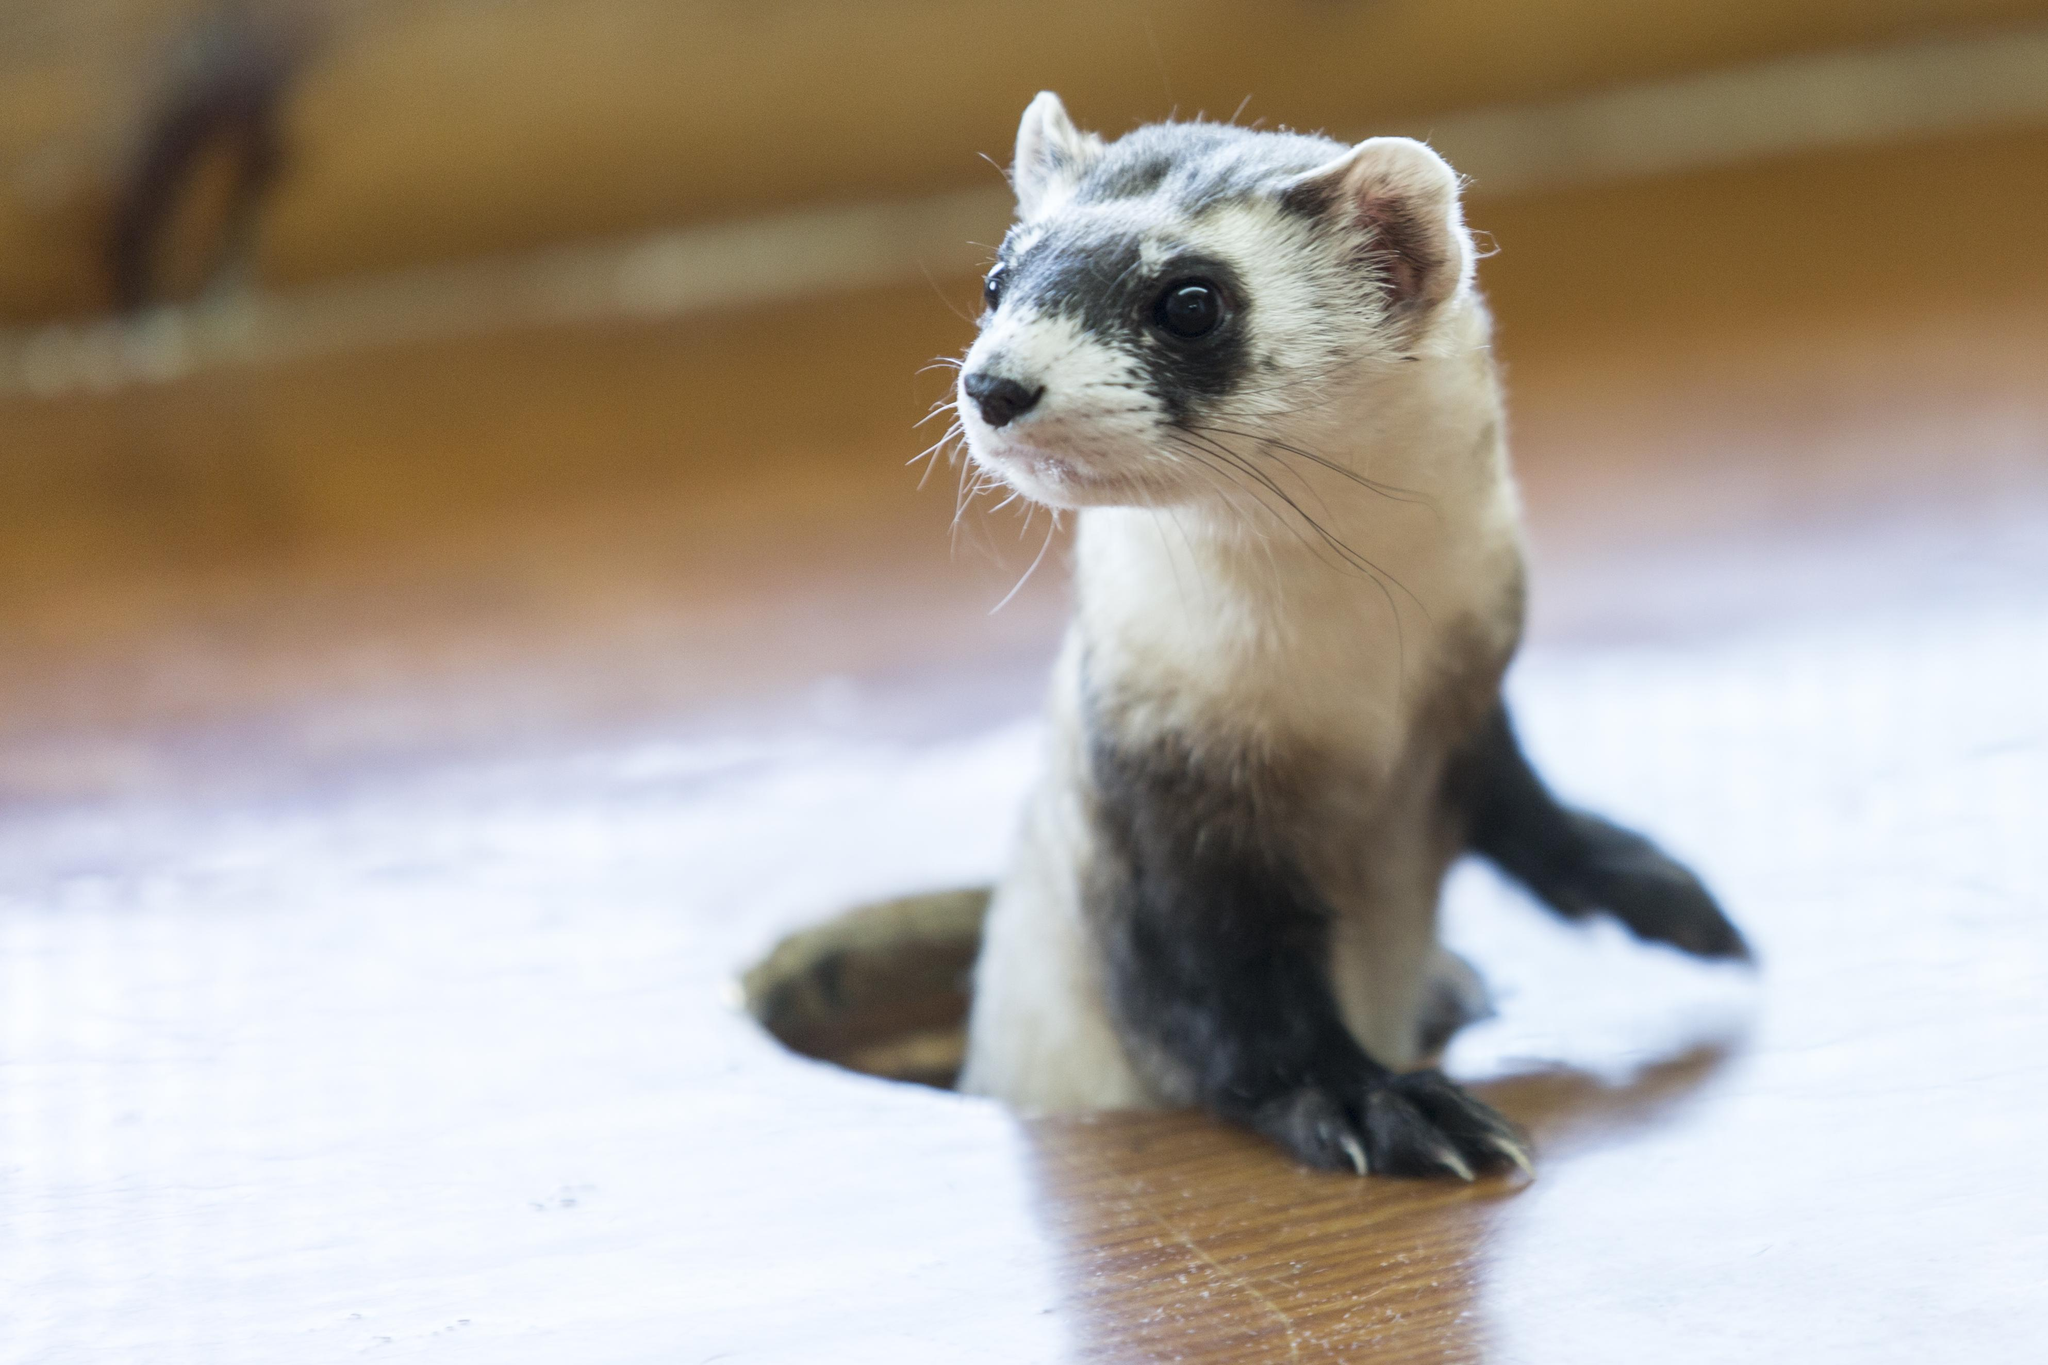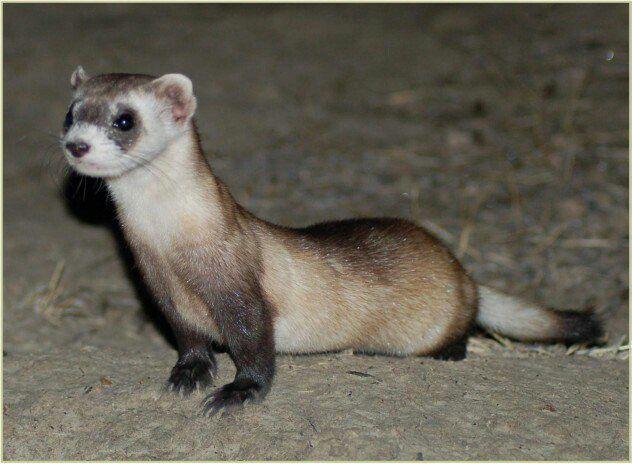The first image is the image on the left, the second image is the image on the right. Considering the images on both sides, is "There is one ferret emerging from a hole and another ferret standing on some dirt." valid? Answer yes or no. Yes. The first image is the image on the left, the second image is the image on the right. For the images shown, is this caption "A ferret is popping up through a hole inside a metal wire cage." true? Answer yes or no. No. 